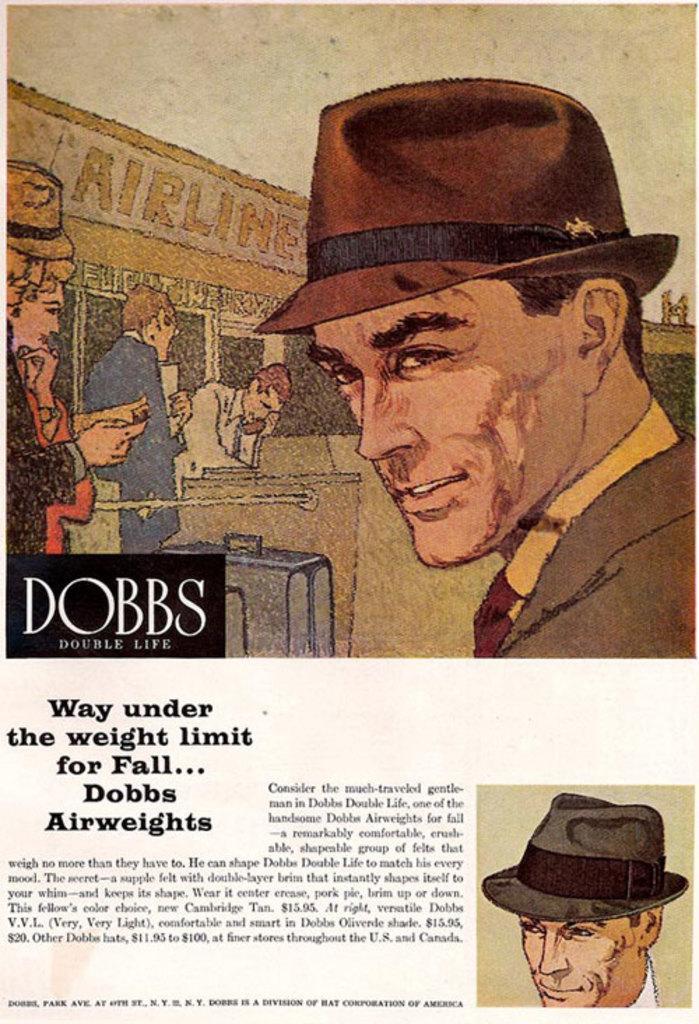Can you describe this image briefly? This is a poster. On the poster we can see pictures of persons and text written on it. 